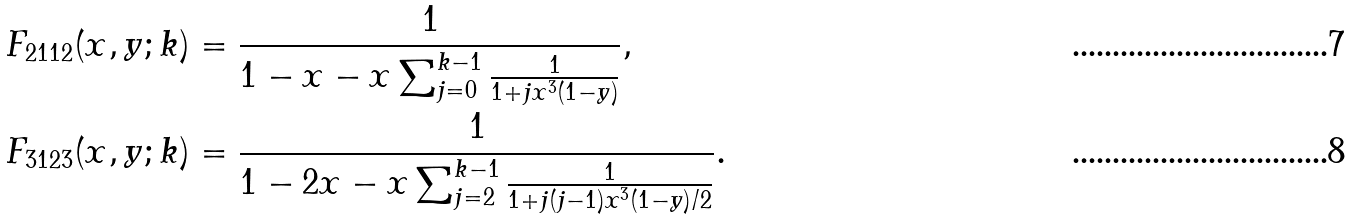<formula> <loc_0><loc_0><loc_500><loc_500>F _ { 2 1 1 2 } ( x , y ; k ) & = \frac { 1 } { 1 - x - x \sum _ { j = 0 } ^ { k - 1 } \frac { 1 } { 1 + j x ^ { 3 } ( 1 - y ) } } , \\ F _ { 3 1 2 3 } ( x , y ; k ) & = \frac { 1 } { 1 - 2 x - x \sum _ { j = 2 } ^ { k - 1 } \frac { 1 } { 1 + j ( j - 1 ) x ^ { 3 } ( 1 - y ) / 2 } } .</formula> 